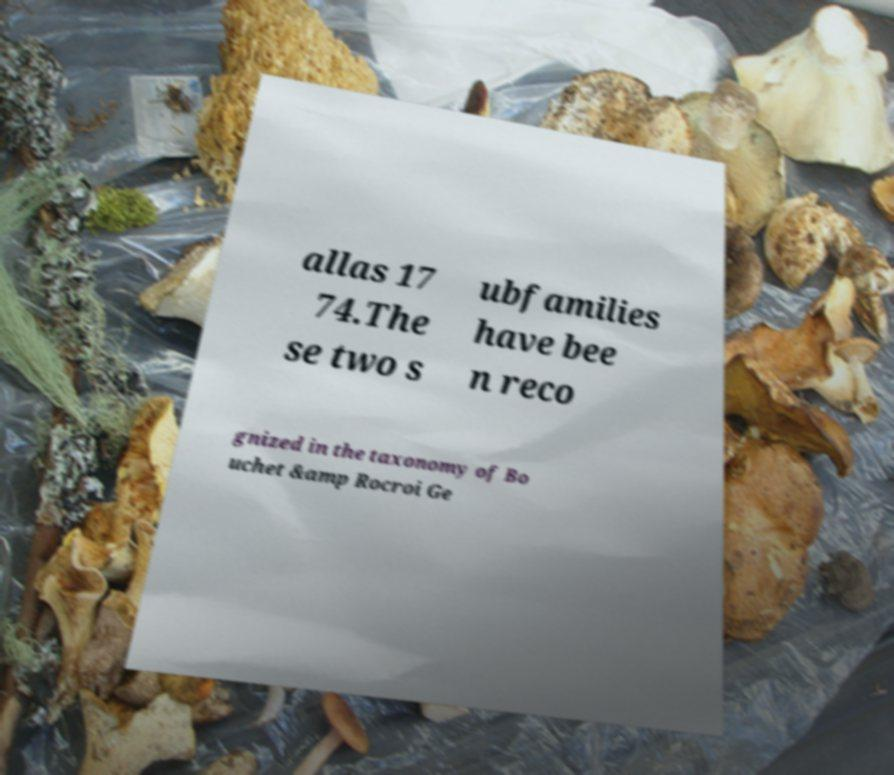Could you extract and type out the text from this image? allas 17 74.The se two s ubfamilies have bee n reco gnized in the taxonomy of Bo uchet &amp Rocroi Ge 